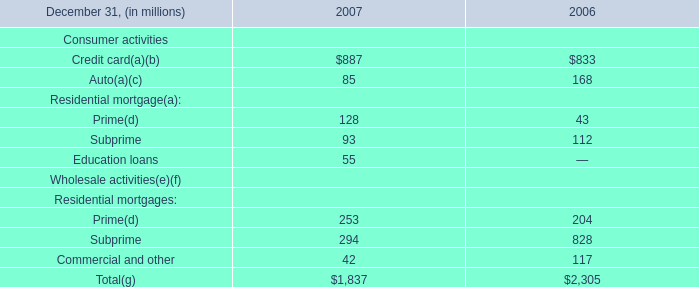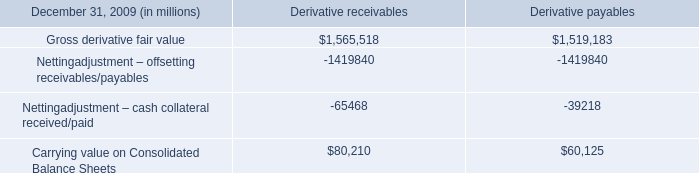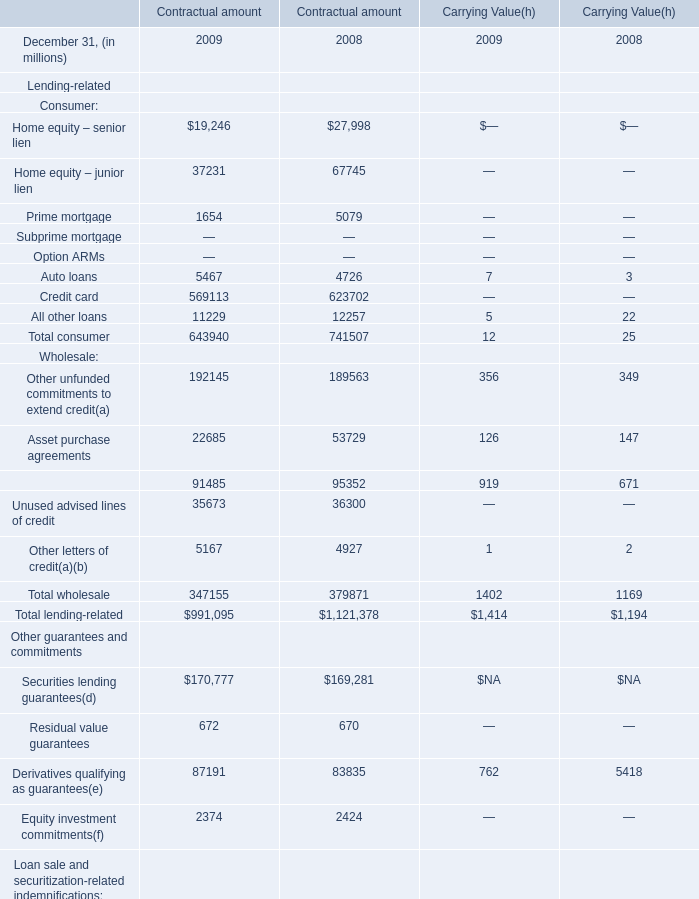Which year is Total wholesale at Carrying Value larger? 
Answer: 2009. 